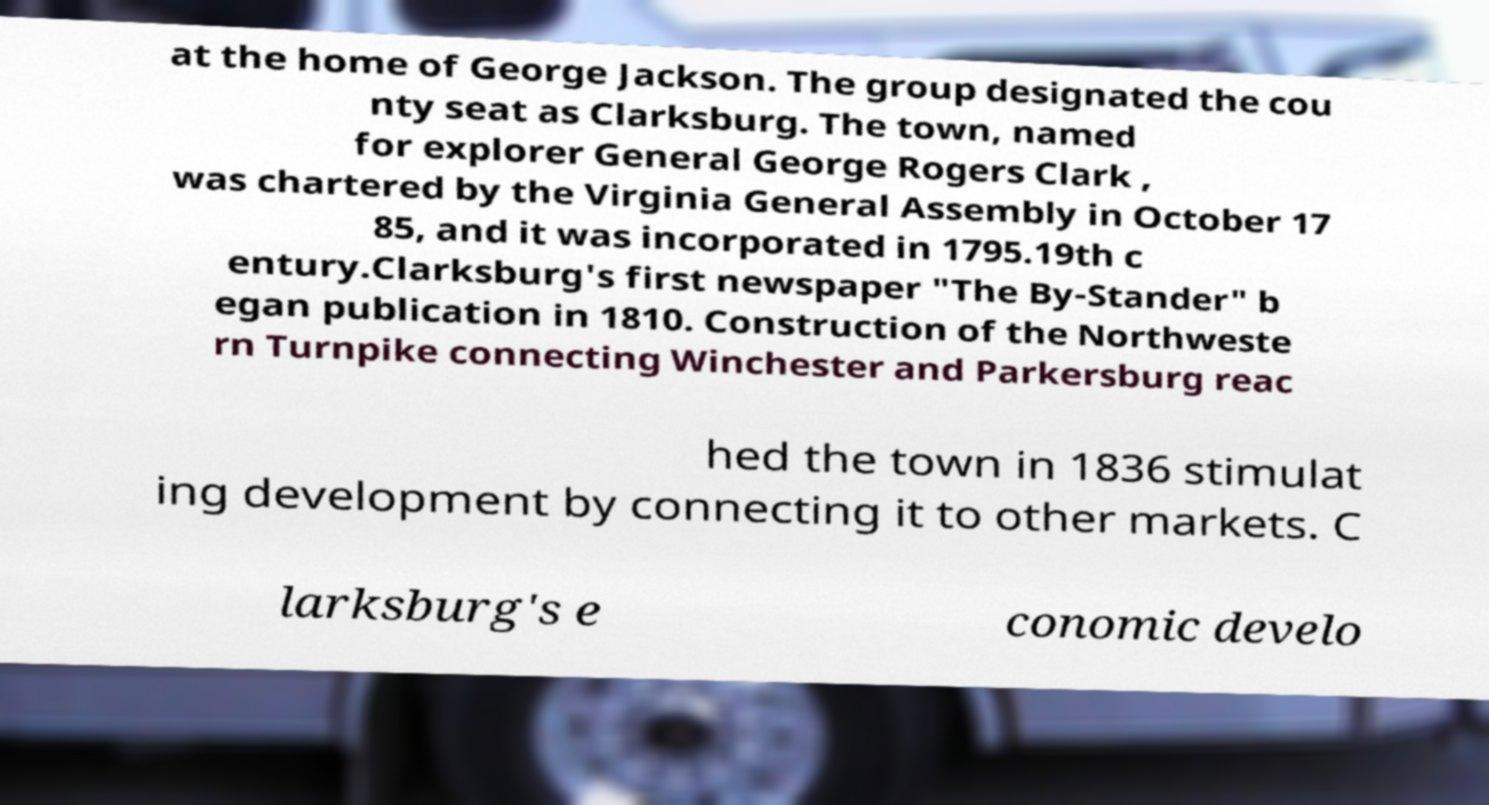I need the written content from this picture converted into text. Can you do that? at the home of George Jackson. The group designated the cou nty seat as Clarksburg. The town, named for explorer General George Rogers Clark , was chartered by the Virginia General Assembly in October 17 85, and it was incorporated in 1795.19th c entury.Clarksburg's first newspaper "The By-Stander" b egan publication in 1810. Construction of the Northweste rn Turnpike connecting Winchester and Parkersburg reac hed the town in 1836 stimulat ing development by connecting it to other markets. C larksburg's e conomic develo 